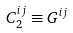<formula> <loc_0><loc_0><loc_500><loc_500>C _ { 2 } ^ { i j } \equiv G ^ { i j }</formula> 